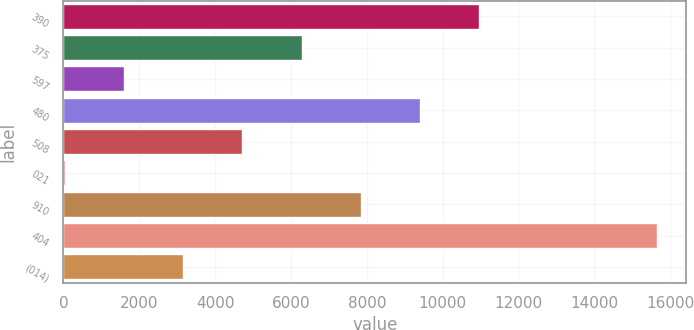Convert chart to OTSL. <chart><loc_0><loc_0><loc_500><loc_500><bar_chart><fcel>390<fcel>375<fcel>597<fcel>480<fcel>508<fcel>021<fcel>910<fcel>404<fcel>(014)<nl><fcel>10964.5<fcel>6280<fcel>1595.5<fcel>9403<fcel>4718.5<fcel>34<fcel>7841.5<fcel>15649<fcel>3157<nl></chart> 